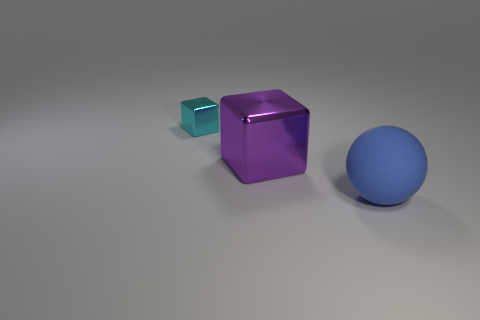What is the color of the big metallic block?
Provide a short and direct response. Purple. What number of other cubes are the same material as the large purple cube?
Give a very brief answer. 1. Is the number of small red shiny blocks greater than the number of cyan metal objects?
Provide a succinct answer. No. What number of rubber spheres are to the right of the metal object right of the small cyan metal object?
Offer a very short reply. 1. What number of things are objects that are behind the blue object or big balls?
Your answer should be compact. 3. Are there any purple things that have the same shape as the big blue thing?
Offer a terse response. No. What is the shape of the big object right of the shiny block to the right of the cyan shiny thing?
Provide a short and direct response. Sphere. How many cylinders are big purple metal things or brown rubber things?
Provide a succinct answer. 0. Do the large thing that is behind the big rubber thing and the big matte thing in front of the tiny metallic thing have the same shape?
Offer a terse response. No. There is a big sphere; is it the same color as the metallic cube that is in front of the cyan object?
Provide a succinct answer. No. 